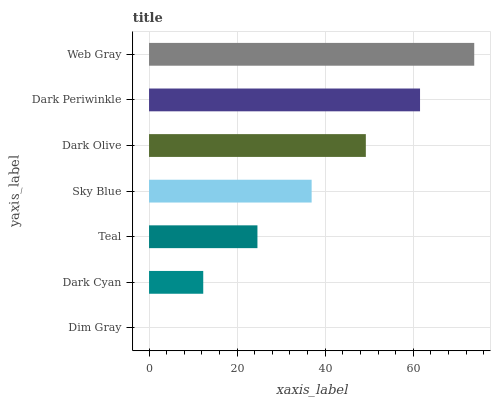Is Dim Gray the minimum?
Answer yes or no. Yes. Is Web Gray the maximum?
Answer yes or no. Yes. Is Dark Cyan the minimum?
Answer yes or no. No. Is Dark Cyan the maximum?
Answer yes or no. No. Is Dark Cyan greater than Dim Gray?
Answer yes or no. Yes. Is Dim Gray less than Dark Cyan?
Answer yes or no. Yes. Is Dim Gray greater than Dark Cyan?
Answer yes or no. No. Is Dark Cyan less than Dim Gray?
Answer yes or no. No. Is Sky Blue the high median?
Answer yes or no. Yes. Is Sky Blue the low median?
Answer yes or no. Yes. Is Dark Periwinkle the high median?
Answer yes or no. No. Is Dark Cyan the low median?
Answer yes or no. No. 